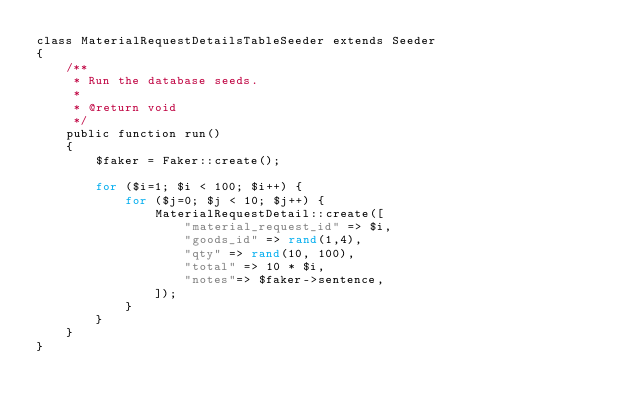<code> <loc_0><loc_0><loc_500><loc_500><_PHP_>class MaterialRequestDetailsTableSeeder extends Seeder
{
    /**
     * Run the database seeds.
     *
     * @return void
     */
    public function run()
    {
        $faker = Faker::create();
        
        for ($i=1; $i < 100; $i++) {
            for ($j=0; $j < 10; $j++) {
                MaterialRequestDetail::create([
                    "material_request_id" => $i,
                    "goods_id" => rand(1,4),
                    "qty" => rand(10, 100),
                    "total" => 10 * $i,
                    "notes"=> $faker->sentence,
                ]);
            }
        }
    }
}
</code> 